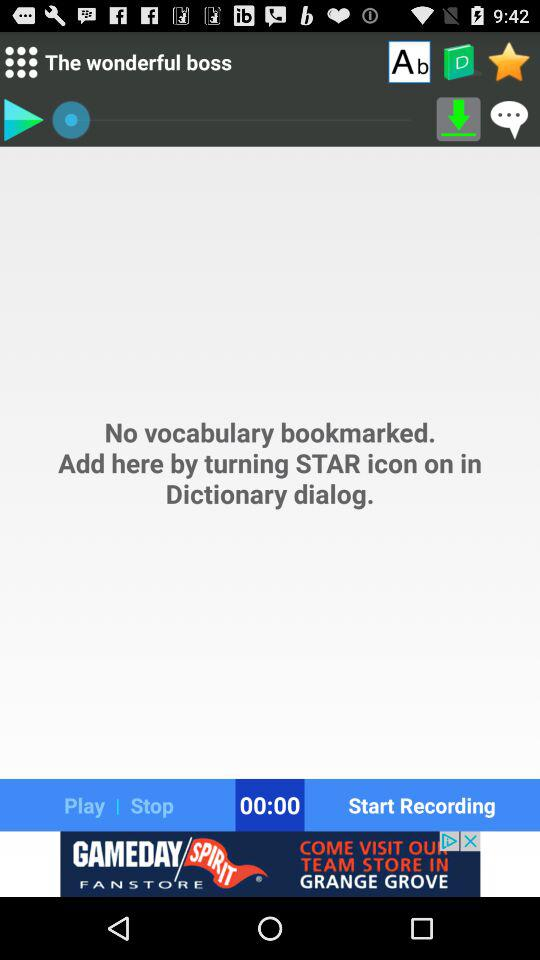What is the first comment on "The wonderful boss"?
When the provided information is insufficient, respond with <no answer>. <no answer> 